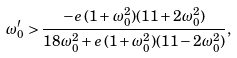<formula> <loc_0><loc_0><loc_500><loc_500>\omega _ { 0 } ^ { \prime } > \frac { - e \, ( 1 + \omega _ { 0 } ^ { 2 } ) ( 1 1 + 2 \omega _ { 0 } ^ { 2 } ) } { 1 8 \omega _ { 0 } ^ { 2 } + e \, ( 1 + \omega _ { 0 } ^ { 2 } ) ( 1 1 - 2 \omega _ { 0 } ^ { 2 } ) } ,</formula> 